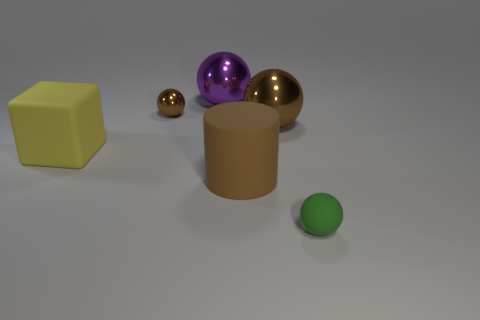Subtract all purple cylinders. How many brown spheres are left? 2 Subtract all metal spheres. How many spheres are left? 1 Add 4 brown rubber things. How many objects exist? 10 Subtract 2 spheres. How many spheres are left? 2 Subtract all purple balls. How many balls are left? 3 Subtract all cubes. How many objects are left? 5 Subtract all green balls. Subtract all green blocks. How many balls are left? 3 Subtract all big yellow matte blocks. Subtract all tiny metal objects. How many objects are left? 4 Add 2 tiny brown things. How many tiny brown things are left? 3 Add 5 green things. How many green things exist? 6 